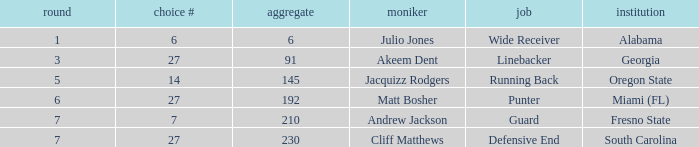Which name had more than 5 rounds and was a defensive end? Cliff Matthews. Can you parse all the data within this table? {'header': ['round', 'choice #', 'aggregate', 'moniker', 'job', 'institution'], 'rows': [['1', '6', '6', 'Julio Jones', 'Wide Receiver', 'Alabama'], ['3', '27', '91', 'Akeem Dent', 'Linebacker', 'Georgia'], ['5', '14', '145', 'Jacquizz Rodgers', 'Running Back', 'Oregon State'], ['6', '27', '192', 'Matt Bosher', 'Punter', 'Miami (FL)'], ['7', '7', '210', 'Andrew Jackson', 'Guard', 'Fresno State'], ['7', '27', '230', 'Cliff Matthews', 'Defensive End', 'South Carolina']]} 